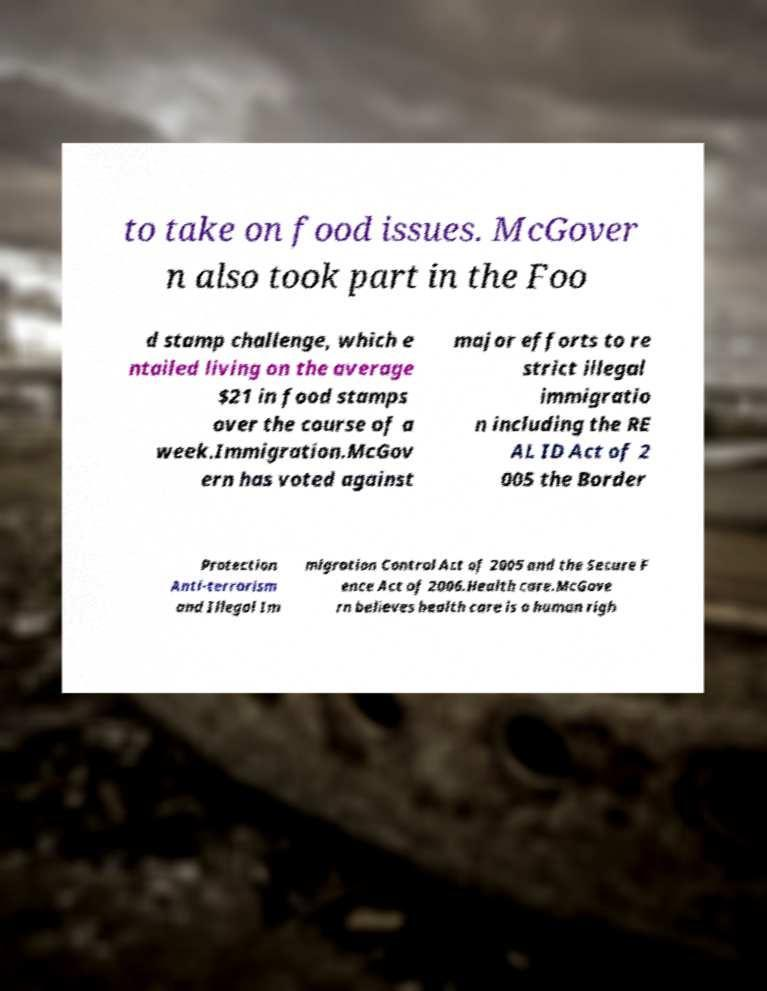Can you accurately transcribe the text from the provided image for me? to take on food issues. McGover n also took part in the Foo d stamp challenge, which e ntailed living on the average $21 in food stamps over the course of a week.Immigration.McGov ern has voted against major efforts to re strict illegal immigratio n including the RE AL ID Act of 2 005 the Border Protection Anti-terrorism and Illegal Im migration Control Act of 2005 and the Secure F ence Act of 2006.Health care.McGove rn believes health care is a human righ 